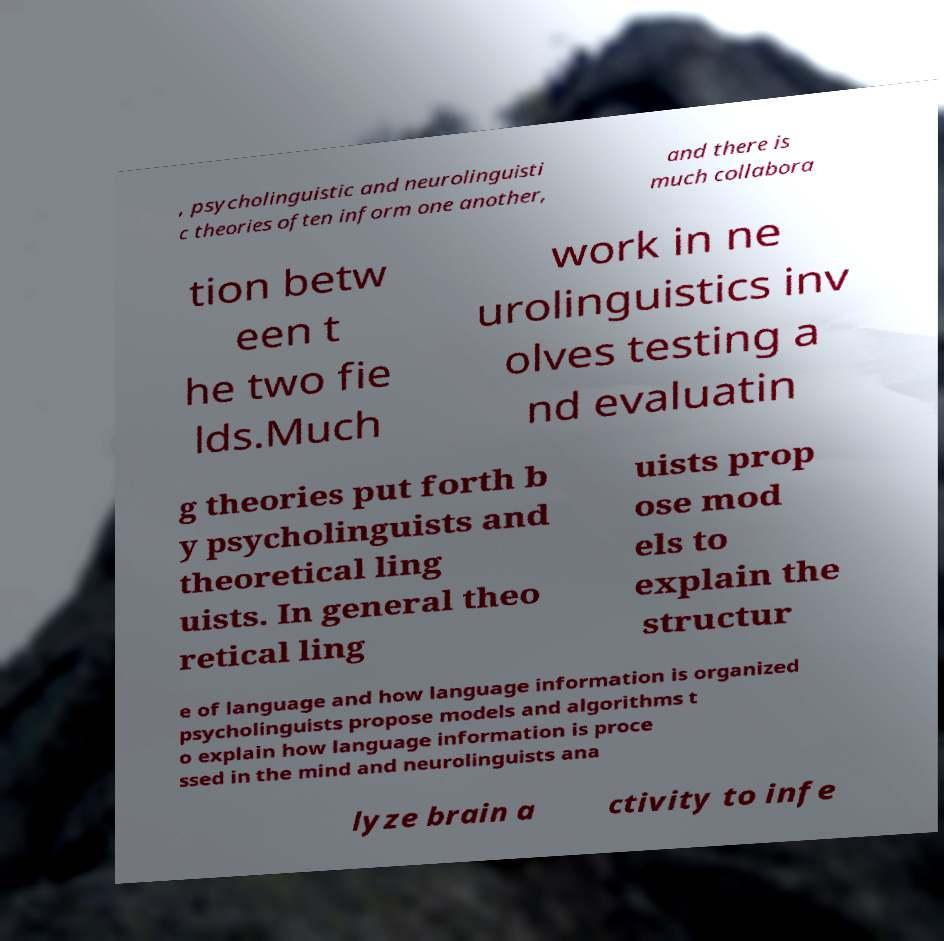Please identify and transcribe the text found in this image. , psycholinguistic and neurolinguisti c theories often inform one another, and there is much collabora tion betw een t he two fie lds.Much work in ne urolinguistics inv olves testing a nd evaluatin g theories put forth b y psycholinguists and theoretical ling uists. In general theo retical ling uists prop ose mod els to explain the structur e of language and how language information is organized psycholinguists propose models and algorithms t o explain how language information is proce ssed in the mind and neurolinguists ana lyze brain a ctivity to infe 